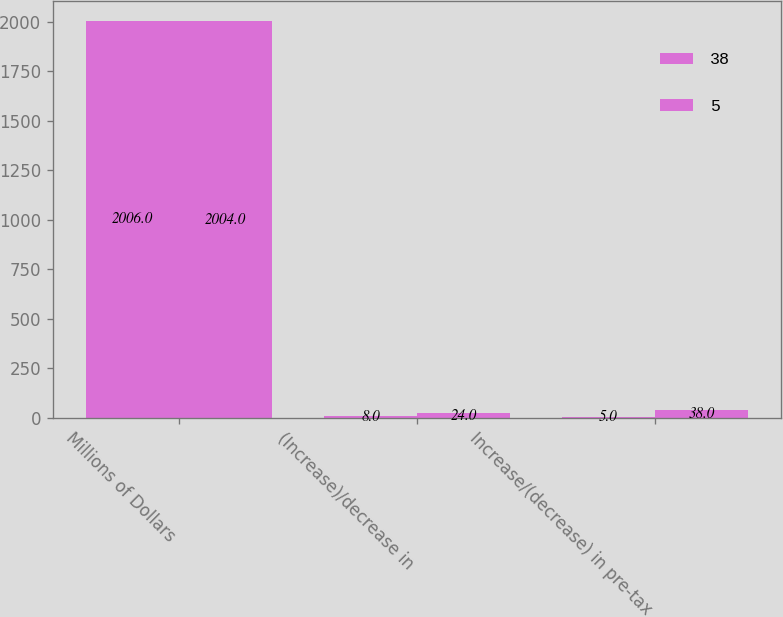Convert chart to OTSL. <chart><loc_0><loc_0><loc_500><loc_500><stacked_bar_chart><ecel><fcel>Millions of Dollars<fcel>(Increase)/decrease in<fcel>Increase/(decrease) in pre-tax<nl><fcel>38<fcel>2006<fcel>8<fcel>5<nl><fcel>5<fcel>2004<fcel>24<fcel>38<nl></chart> 